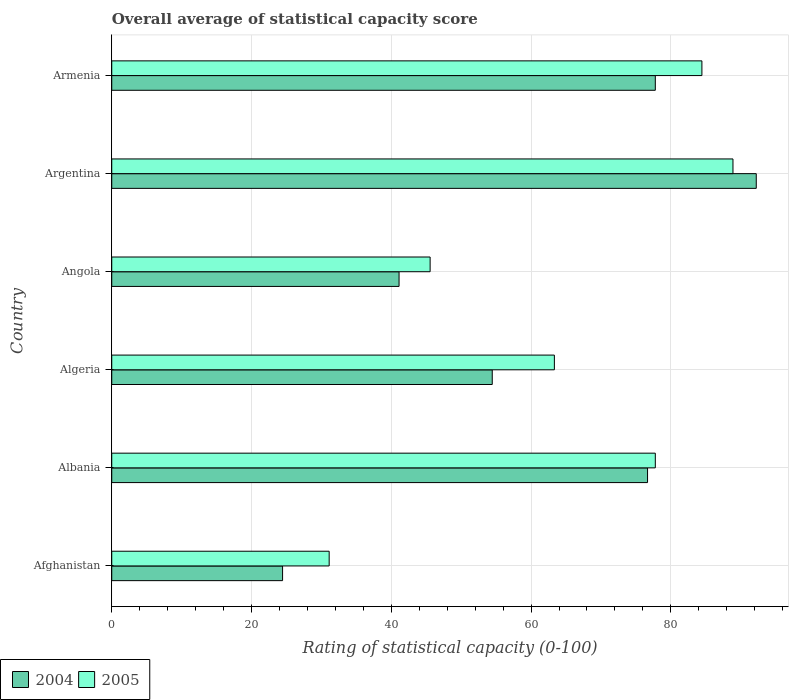How many different coloured bars are there?
Make the answer very short. 2. Are the number of bars per tick equal to the number of legend labels?
Offer a very short reply. Yes. How many bars are there on the 5th tick from the top?
Provide a succinct answer. 2. How many bars are there on the 2nd tick from the bottom?
Provide a short and direct response. 2. What is the label of the 6th group of bars from the top?
Keep it short and to the point. Afghanistan. In how many cases, is the number of bars for a given country not equal to the number of legend labels?
Offer a very short reply. 0. What is the rating of statistical capacity in 2005 in Algeria?
Your response must be concise. 63.33. Across all countries, what is the maximum rating of statistical capacity in 2004?
Offer a terse response. 92.22. Across all countries, what is the minimum rating of statistical capacity in 2005?
Provide a succinct answer. 31.11. In which country was the rating of statistical capacity in 2005 minimum?
Offer a very short reply. Afghanistan. What is the total rating of statistical capacity in 2005 in the graph?
Your answer should be compact. 391.11. What is the difference between the rating of statistical capacity in 2004 in Albania and that in Armenia?
Your answer should be very brief. -1.11. What is the difference between the rating of statistical capacity in 2005 in Algeria and the rating of statistical capacity in 2004 in Afghanistan?
Keep it short and to the point. 38.89. What is the average rating of statistical capacity in 2005 per country?
Offer a very short reply. 65.19. What is the difference between the rating of statistical capacity in 2004 and rating of statistical capacity in 2005 in Afghanistan?
Give a very brief answer. -6.67. In how many countries, is the rating of statistical capacity in 2004 greater than 60 ?
Your response must be concise. 3. What is the ratio of the rating of statistical capacity in 2004 in Albania to that in Angola?
Provide a short and direct response. 1.86. Is the rating of statistical capacity in 2005 in Albania less than that in Argentina?
Keep it short and to the point. Yes. Is the difference between the rating of statistical capacity in 2004 in Afghanistan and Armenia greater than the difference between the rating of statistical capacity in 2005 in Afghanistan and Armenia?
Keep it short and to the point. No. What is the difference between the highest and the second highest rating of statistical capacity in 2005?
Provide a short and direct response. 4.44. What is the difference between the highest and the lowest rating of statistical capacity in 2004?
Provide a short and direct response. 67.78. Is the sum of the rating of statistical capacity in 2004 in Albania and Angola greater than the maximum rating of statistical capacity in 2005 across all countries?
Your answer should be compact. Yes. What does the 1st bar from the top in Albania represents?
Your response must be concise. 2005. How many bars are there?
Your answer should be very brief. 12. Are all the bars in the graph horizontal?
Give a very brief answer. Yes. How many legend labels are there?
Your answer should be compact. 2. What is the title of the graph?
Your response must be concise. Overall average of statistical capacity score. What is the label or title of the X-axis?
Your response must be concise. Rating of statistical capacity (0-100). What is the label or title of the Y-axis?
Keep it short and to the point. Country. What is the Rating of statistical capacity (0-100) in 2004 in Afghanistan?
Your answer should be very brief. 24.44. What is the Rating of statistical capacity (0-100) in 2005 in Afghanistan?
Offer a very short reply. 31.11. What is the Rating of statistical capacity (0-100) in 2004 in Albania?
Make the answer very short. 76.67. What is the Rating of statistical capacity (0-100) in 2005 in Albania?
Your answer should be very brief. 77.78. What is the Rating of statistical capacity (0-100) in 2004 in Algeria?
Offer a terse response. 54.44. What is the Rating of statistical capacity (0-100) of 2005 in Algeria?
Make the answer very short. 63.33. What is the Rating of statistical capacity (0-100) in 2004 in Angola?
Offer a very short reply. 41.11. What is the Rating of statistical capacity (0-100) in 2005 in Angola?
Your response must be concise. 45.56. What is the Rating of statistical capacity (0-100) in 2004 in Argentina?
Your response must be concise. 92.22. What is the Rating of statistical capacity (0-100) in 2005 in Argentina?
Provide a succinct answer. 88.89. What is the Rating of statistical capacity (0-100) in 2004 in Armenia?
Offer a very short reply. 77.78. What is the Rating of statistical capacity (0-100) of 2005 in Armenia?
Provide a short and direct response. 84.44. Across all countries, what is the maximum Rating of statistical capacity (0-100) in 2004?
Offer a terse response. 92.22. Across all countries, what is the maximum Rating of statistical capacity (0-100) of 2005?
Your response must be concise. 88.89. Across all countries, what is the minimum Rating of statistical capacity (0-100) in 2004?
Give a very brief answer. 24.44. Across all countries, what is the minimum Rating of statistical capacity (0-100) of 2005?
Give a very brief answer. 31.11. What is the total Rating of statistical capacity (0-100) of 2004 in the graph?
Give a very brief answer. 366.67. What is the total Rating of statistical capacity (0-100) in 2005 in the graph?
Offer a very short reply. 391.11. What is the difference between the Rating of statistical capacity (0-100) of 2004 in Afghanistan and that in Albania?
Provide a short and direct response. -52.22. What is the difference between the Rating of statistical capacity (0-100) in 2005 in Afghanistan and that in Albania?
Ensure brevity in your answer.  -46.67. What is the difference between the Rating of statistical capacity (0-100) in 2005 in Afghanistan and that in Algeria?
Make the answer very short. -32.22. What is the difference between the Rating of statistical capacity (0-100) of 2004 in Afghanistan and that in Angola?
Give a very brief answer. -16.67. What is the difference between the Rating of statistical capacity (0-100) in 2005 in Afghanistan and that in Angola?
Your answer should be very brief. -14.44. What is the difference between the Rating of statistical capacity (0-100) in 2004 in Afghanistan and that in Argentina?
Your response must be concise. -67.78. What is the difference between the Rating of statistical capacity (0-100) of 2005 in Afghanistan and that in Argentina?
Offer a very short reply. -57.78. What is the difference between the Rating of statistical capacity (0-100) of 2004 in Afghanistan and that in Armenia?
Offer a terse response. -53.33. What is the difference between the Rating of statistical capacity (0-100) in 2005 in Afghanistan and that in Armenia?
Make the answer very short. -53.33. What is the difference between the Rating of statistical capacity (0-100) of 2004 in Albania and that in Algeria?
Provide a short and direct response. 22.22. What is the difference between the Rating of statistical capacity (0-100) in 2005 in Albania and that in Algeria?
Keep it short and to the point. 14.44. What is the difference between the Rating of statistical capacity (0-100) of 2004 in Albania and that in Angola?
Your answer should be very brief. 35.56. What is the difference between the Rating of statistical capacity (0-100) of 2005 in Albania and that in Angola?
Keep it short and to the point. 32.22. What is the difference between the Rating of statistical capacity (0-100) in 2004 in Albania and that in Argentina?
Provide a succinct answer. -15.56. What is the difference between the Rating of statistical capacity (0-100) of 2005 in Albania and that in Argentina?
Your response must be concise. -11.11. What is the difference between the Rating of statistical capacity (0-100) in 2004 in Albania and that in Armenia?
Provide a short and direct response. -1.11. What is the difference between the Rating of statistical capacity (0-100) of 2005 in Albania and that in Armenia?
Provide a succinct answer. -6.67. What is the difference between the Rating of statistical capacity (0-100) of 2004 in Algeria and that in Angola?
Your response must be concise. 13.33. What is the difference between the Rating of statistical capacity (0-100) in 2005 in Algeria and that in Angola?
Make the answer very short. 17.78. What is the difference between the Rating of statistical capacity (0-100) in 2004 in Algeria and that in Argentina?
Give a very brief answer. -37.78. What is the difference between the Rating of statistical capacity (0-100) of 2005 in Algeria and that in Argentina?
Provide a short and direct response. -25.56. What is the difference between the Rating of statistical capacity (0-100) in 2004 in Algeria and that in Armenia?
Make the answer very short. -23.33. What is the difference between the Rating of statistical capacity (0-100) of 2005 in Algeria and that in Armenia?
Offer a very short reply. -21.11. What is the difference between the Rating of statistical capacity (0-100) in 2004 in Angola and that in Argentina?
Your answer should be very brief. -51.11. What is the difference between the Rating of statistical capacity (0-100) in 2005 in Angola and that in Argentina?
Your answer should be very brief. -43.33. What is the difference between the Rating of statistical capacity (0-100) in 2004 in Angola and that in Armenia?
Make the answer very short. -36.67. What is the difference between the Rating of statistical capacity (0-100) in 2005 in Angola and that in Armenia?
Keep it short and to the point. -38.89. What is the difference between the Rating of statistical capacity (0-100) in 2004 in Argentina and that in Armenia?
Your response must be concise. 14.44. What is the difference between the Rating of statistical capacity (0-100) in 2005 in Argentina and that in Armenia?
Ensure brevity in your answer.  4.44. What is the difference between the Rating of statistical capacity (0-100) of 2004 in Afghanistan and the Rating of statistical capacity (0-100) of 2005 in Albania?
Your answer should be compact. -53.33. What is the difference between the Rating of statistical capacity (0-100) in 2004 in Afghanistan and the Rating of statistical capacity (0-100) in 2005 in Algeria?
Make the answer very short. -38.89. What is the difference between the Rating of statistical capacity (0-100) in 2004 in Afghanistan and the Rating of statistical capacity (0-100) in 2005 in Angola?
Your response must be concise. -21.11. What is the difference between the Rating of statistical capacity (0-100) in 2004 in Afghanistan and the Rating of statistical capacity (0-100) in 2005 in Argentina?
Provide a succinct answer. -64.44. What is the difference between the Rating of statistical capacity (0-100) in 2004 in Afghanistan and the Rating of statistical capacity (0-100) in 2005 in Armenia?
Provide a succinct answer. -60. What is the difference between the Rating of statistical capacity (0-100) in 2004 in Albania and the Rating of statistical capacity (0-100) in 2005 in Algeria?
Offer a very short reply. 13.33. What is the difference between the Rating of statistical capacity (0-100) of 2004 in Albania and the Rating of statistical capacity (0-100) of 2005 in Angola?
Your response must be concise. 31.11. What is the difference between the Rating of statistical capacity (0-100) in 2004 in Albania and the Rating of statistical capacity (0-100) in 2005 in Argentina?
Provide a succinct answer. -12.22. What is the difference between the Rating of statistical capacity (0-100) of 2004 in Albania and the Rating of statistical capacity (0-100) of 2005 in Armenia?
Your answer should be very brief. -7.78. What is the difference between the Rating of statistical capacity (0-100) in 2004 in Algeria and the Rating of statistical capacity (0-100) in 2005 in Angola?
Your response must be concise. 8.89. What is the difference between the Rating of statistical capacity (0-100) in 2004 in Algeria and the Rating of statistical capacity (0-100) in 2005 in Argentina?
Offer a very short reply. -34.44. What is the difference between the Rating of statistical capacity (0-100) of 2004 in Angola and the Rating of statistical capacity (0-100) of 2005 in Argentina?
Keep it short and to the point. -47.78. What is the difference between the Rating of statistical capacity (0-100) of 2004 in Angola and the Rating of statistical capacity (0-100) of 2005 in Armenia?
Make the answer very short. -43.33. What is the difference between the Rating of statistical capacity (0-100) in 2004 in Argentina and the Rating of statistical capacity (0-100) in 2005 in Armenia?
Provide a succinct answer. 7.78. What is the average Rating of statistical capacity (0-100) in 2004 per country?
Offer a terse response. 61.11. What is the average Rating of statistical capacity (0-100) in 2005 per country?
Offer a terse response. 65.19. What is the difference between the Rating of statistical capacity (0-100) in 2004 and Rating of statistical capacity (0-100) in 2005 in Afghanistan?
Provide a short and direct response. -6.67. What is the difference between the Rating of statistical capacity (0-100) in 2004 and Rating of statistical capacity (0-100) in 2005 in Albania?
Your answer should be very brief. -1.11. What is the difference between the Rating of statistical capacity (0-100) of 2004 and Rating of statistical capacity (0-100) of 2005 in Algeria?
Ensure brevity in your answer.  -8.89. What is the difference between the Rating of statistical capacity (0-100) in 2004 and Rating of statistical capacity (0-100) in 2005 in Angola?
Keep it short and to the point. -4.44. What is the difference between the Rating of statistical capacity (0-100) in 2004 and Rating of statistical capacity (0-100) in 2005 in Armenia?
Your answer should be compact. -6.67. What is the ratio of the Rating of statistical capacity (0-100) of 2004 in Afghanistan to that in Albania?
Keep it short and to the point. 0.32. What is the ratio of the Rating of statistical capacity (0-100) in 2004 in Afghanistan to that in Algeria?
Give a very brief answer. 0.45. What is the ratio of the Rating of statistical capacity (0-100) of 2005 in Afghanistan to that in Algeria?
Your response must be concise. 0.49. What is the ratio of the Rating of statistical capacity (0-100) of 2004 in Afghanistan to that in Angola?
Your response must be concise. 0.59. What is the ratio of the Rating of statistical capacity (0-100) in 2005 in Afghanistan to that in Angola?
Give a very brief answer. 0.68. What is the ratio of the Rating of statistical capacity (0-100) of 2004 in Afghanistan to that in Argentina?
Keep it short and to the point. 0.27. What is the ratio of the Rating of statistical capacity (0-100) in 2005 in Afghanistan to that in Argentina?
Ensure brevity in your answer.  0.35. What is the ratio of the Rating of statistical capacity (0-100) of 2004 in Afghanistan to that in Armenia?
Offer a terse response. 0.31. What is the ratio of the Rating of statistical capacity (0-100) in 2005 in Afghanistan to that in Armenia?
Keep it short and to the point. 0.37. What is the ratio of the Rating of statistical capacity (0-100) of 2004 in Albania to that in Algeria?
Your answer should be very brief. 1.41. What is the ratio of the Rating of statistical capacity (0-100) of 2005 in Albania to that in Algeria?
Your response must be concise. 1.23. What is the ratio of the Rating of statistical capacity (0-100) of 2004 in Albania to that in Angola?
Make the answer very short. 1.86. What is the ratio of the Rating of statistical capacity (0-100) in 2005 in Albania to that in Angola?
Provide a short and direct response. 1.71. What is the ratio of the Rating of statistical capacity (0-100) in 2004 in Albania to that in Argentina?
Keep it short and to the point. 0.83. What is the ratio of the Rating of statistical capacity (0-100) of 2005 in Albania to that in Argentina?
Give a very brief answer. 0.88. What is the ratio of the Rating of statistical capacity (0-100) of 2004 in Albania to that in Armenia?
Ensure brevity in your answer.  0.99. What is the ratio of the Rating of statistical capacity (0-100) of 2005 in Albania to that in Armenia?
Make the answer very short. 0.92. What is the ratio of the Rating of statistical capacity (0-100) in 2004 in Algeria to that in Angola?
Provide a succinct answer. 1.32. What is the ratio of the Rating of statistical capacity (0-100) of 2005 in Algeria to that in Angola?
Offer a very short reply. 1.39. What is the ratio of the Rating of statistical capacity (0-100) in 2004 in Algeria to that in Argentina?
Your answer should be very brief. 0.59. What is the ratio of the Rating of statistical capacity (0-100) in 2005 in Algeria to that in Argentina?
Provide a succinct answer. 0.71. What is the ratio of the Rating of statistical capacity (0-100) of 2005 in Algeria to that in Armenia?
Keep it short and to the point. 0.75. What is the ratio of the Rating of statistical capacity (0-100) of 2004 in Angola to that in Argentina?
Your answer should be compact. 0.45. What is the ratio of the Rating of statistical capacity (0-100) of 2005 in Angola to that in Argentina?
Provide a short and direct response. 0.51. What is the ratio of the Rating of statistical capacity (0-100) of 2004 in Angola to that in Armenia?
Your answer should be compact. 0.53. What is the ratio of the Rating of statistical capacity (0-100) of 2005 in Angola to that in Armenia?
Make the answer very short. 0.54. What is the ratio of the Rating of statistical capacity (0-100) of 2004 in Argentina to that in Armenia?
Your response must be concise. 1.19. What is the ratio of the Rating of statistical capacity (0-100) of 2005 in Argentina to that in Armenia?
Provide a short and direct response. 1.05. What is the difference between the highest and the second highest Rating of statistical capacity (0-100) of 2004?
Offer a terse response. 14.44. What is the difference between the highest and the second highest Rating of statistical capacity (0-100) of 2005?
Make the answer very short. 4.44. What is the difference between the highest and the lowest Rating of statistical capacity (0-100) of 2004?
Your response must be concise. 67.78. What is the difference between the highest and the lowest Rating of statistical capacity (0-100) of 2005?
Your answer should be very brief. 57.78. 